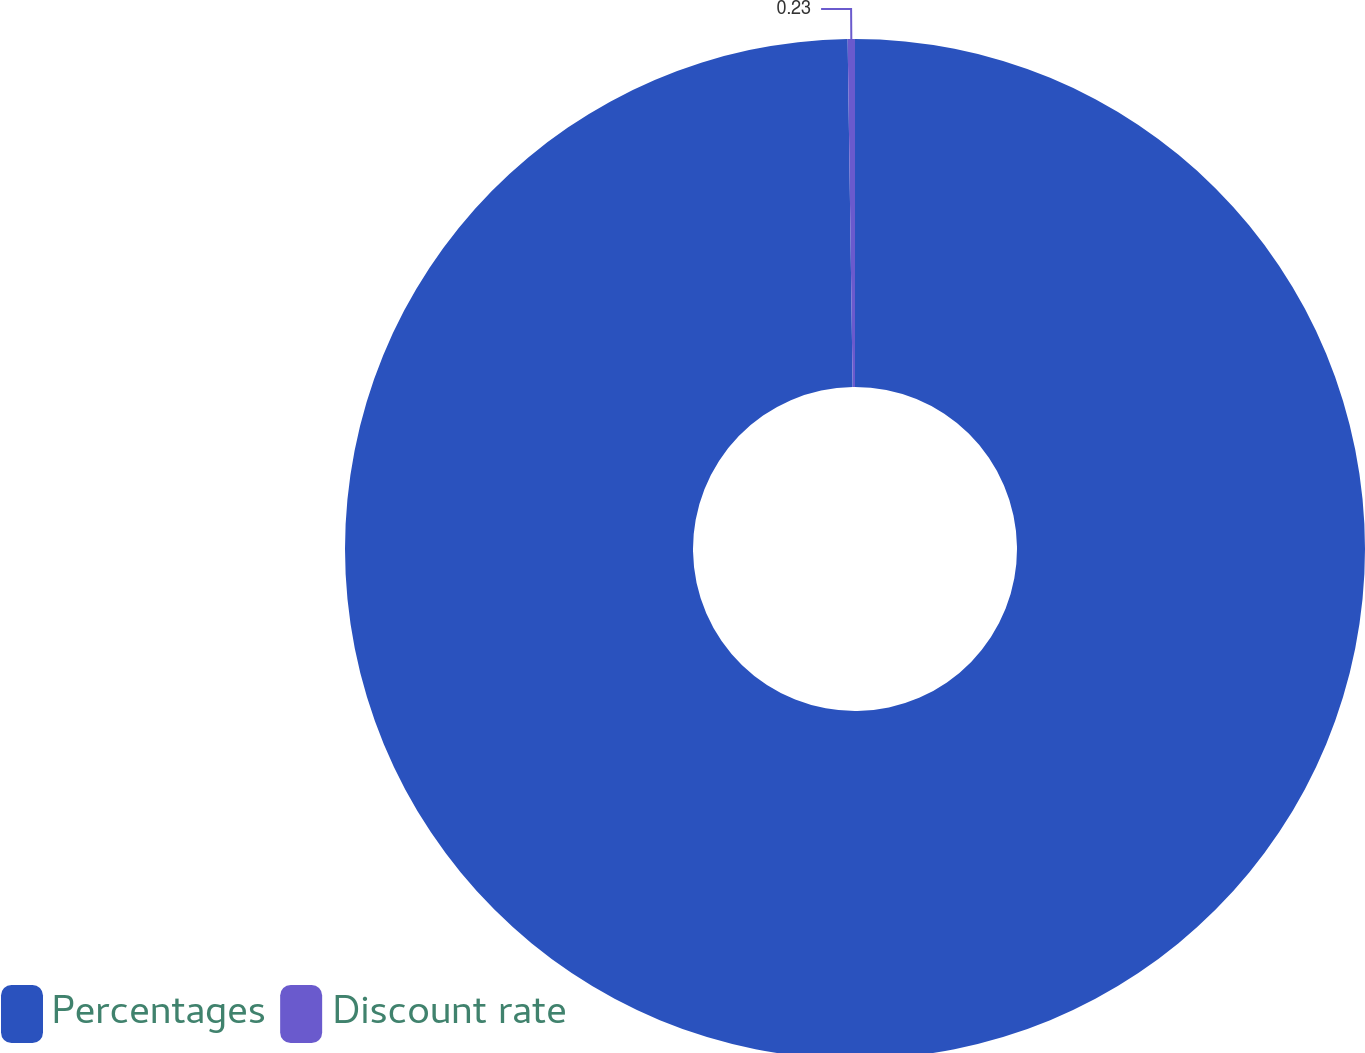Convert chart. <chart><loc_0><loc_0><loc_500><loc_500><pie_chart><fcel>Percentages<fcel>Discount rate<nl><fcel>99.77%<fcel>0.23%<nl></chart> 